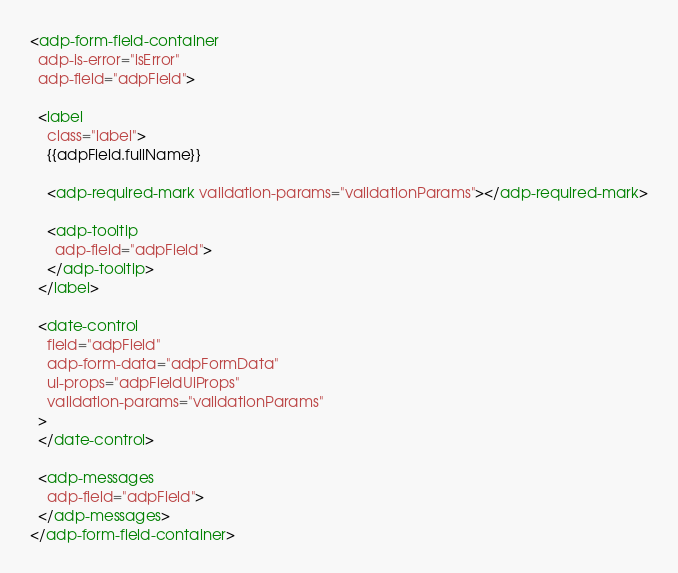Convert code to text. <code><loc_0><loc_0><loc_500><loc_500><_HTML_><adp-form-field-container
  adp-is-error="isError"
  adp-field="adpField">

  <label
    class="label">
    {{adpField.fullName}}

    <adp-required-mark validation-params="validationParams"></adp-required-mark>

    <adp-tooltip
      adp-field="adpField">
    </adp-tooltip>
  </label>

  <date-control
    field="adpField"
    adp-form-data="adpFormData"
    ui-props="adpFieldUiProps"
    validation-params="validationParams"
  >
  </date-control>

  <adp-messages
    adp-field="adpField">
  </adp-messages>
</adp-form-field-container></code> 